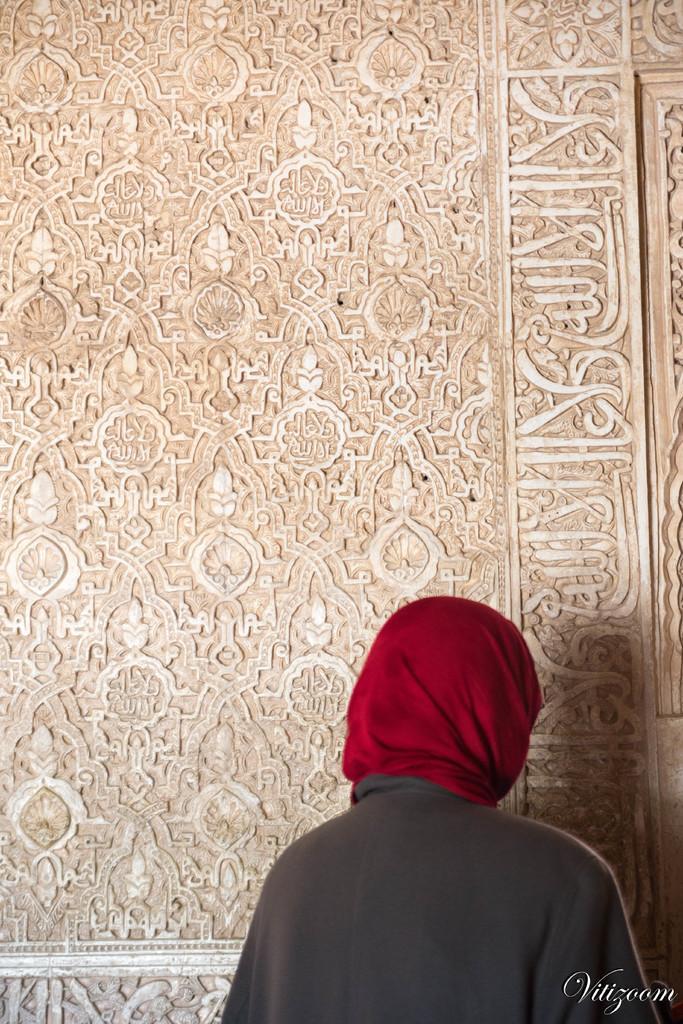Describe this image in one or two sentences. At the bottom of the image there is a lady. There is some text. In the background of the image there is wall with carvings. 